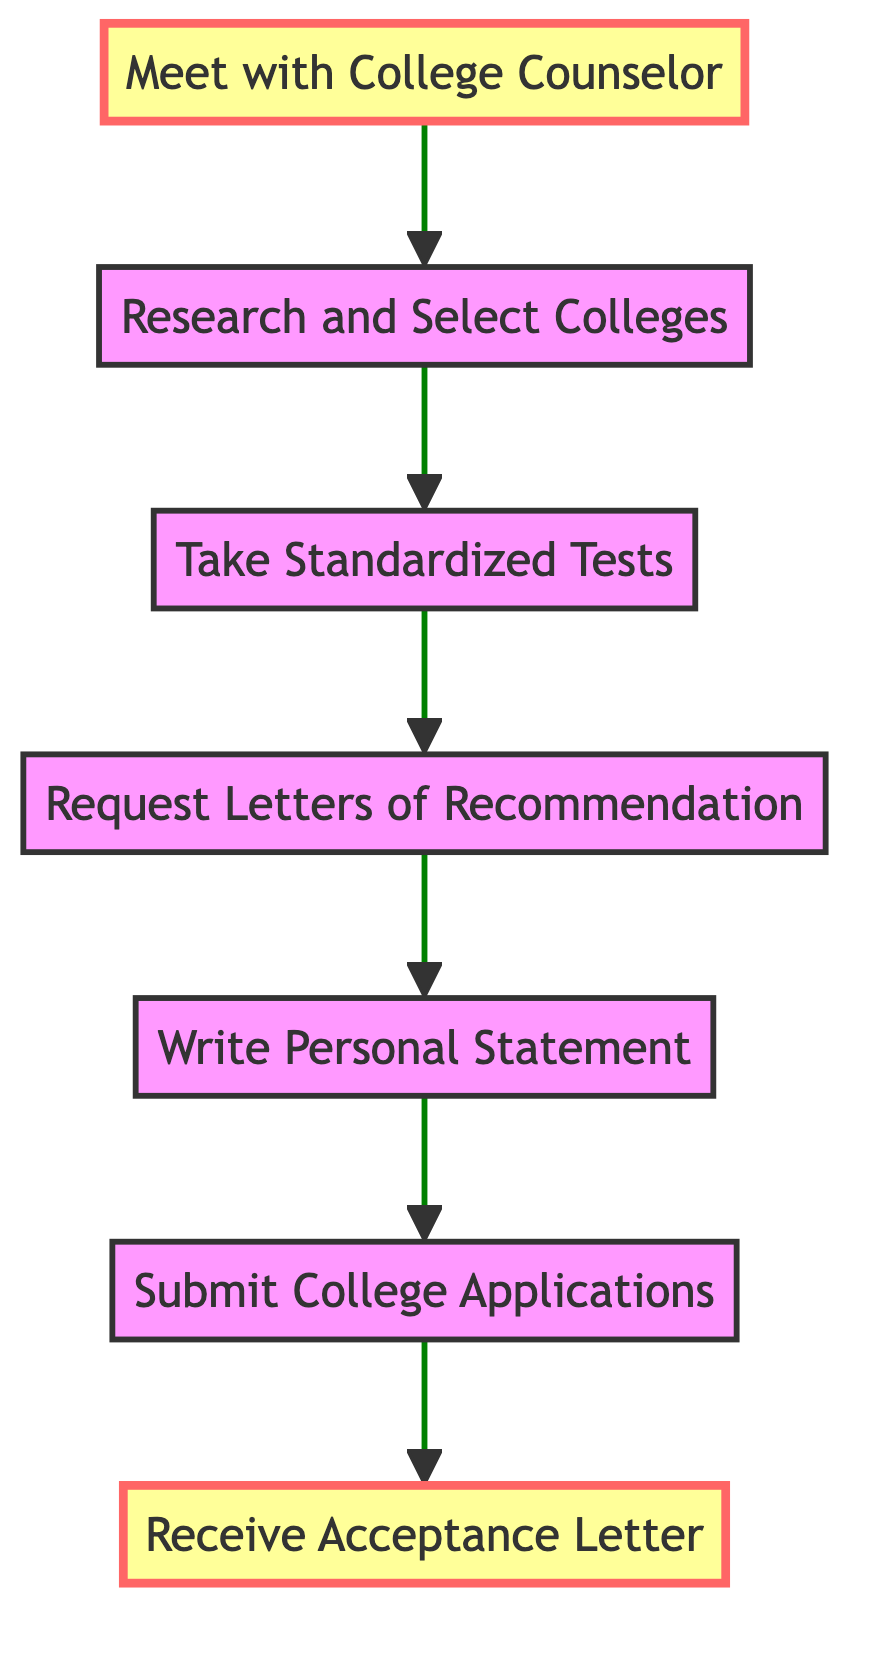What is the first step in the college application process? The first step according to the diagram is "Meet with College Counselor," which is the starting point of the flow.
Answer: Meet with College Counselor How many total steps are illustrated in the diagram? The diagram illustrates a total of seven steps, starting from "Meet with College Counselor" to "Receive Acceptance Letter."
Answer: 7 What step comes immediately after writing a personal statement? After "Write Personal Statement," the next step according to the flow is "Submit College Applications."
Answer: Submit College Applications Which step is directly linked to taking standardized tests? The step directly linked to "Take Standardized Tests" is "Research and Select Colleges," as it appears immediately before it in the flow.
Answer: Research and Select Colleges What is the last step in the college application process? The last step in the process, as indicated at the top of the flow, is "Receive Acceptance Letter." This is the outcome of all prior actions.
Answer: Receive Acceptance Letter Which step involves seeking help from teachers? The step that involves seeking assistance from teachers is "Request Letters of Recommendation," since it specifically mentions asking teachers or mentors for support.
Answer: Request Letters of Recommendation How many steps are between meeting with the college counselor and submitting college applications? There are four steps between "Meet with College Counselor" and "Submit College Applications," which are "Research and Select Colleges," "Take Standardized Tests," "Request Letters of Recommendation," and "Write Personal Statement."
Answer: 4 What is the common goal of the process outlined in the diagram? The common goal of the process is to successfully prepare for college applications, culminating in receiving an acceptance letter.
Answer: Prepare for college applications 